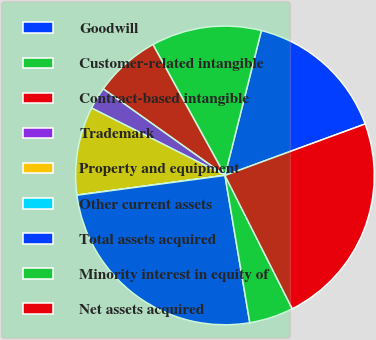<chart> <loc_0><loc_0><loc_500><loc_500><pie_chart><fcel>Goodwill<fcel>Customer-related intangible<fcel>Contract-based intangible<fcel>Trademark<fcel>Property and equipment<fcel>Other current assets<fcel>Total assets acquired<fcel>Minority interest in equity of<fcel>Net assets acquired<nl><fcel>15.48%<fcel>11.93%<fcel>7.16%<fcel>2.39%<fcel>9.55%<fcel>0.01%<fcel>25.55%<fcel>4.78%<fcel>23.16%<nl></chart> 